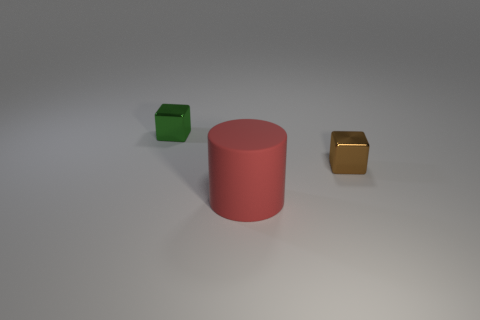Can you tell me the colors of the smaller objects beside the red cylinder? Certainly! To the left of the red cylinder, there is a small green object with a cube-like shape. To the right, there is a smaller object resembling a cube as well, and it has a golden color. 